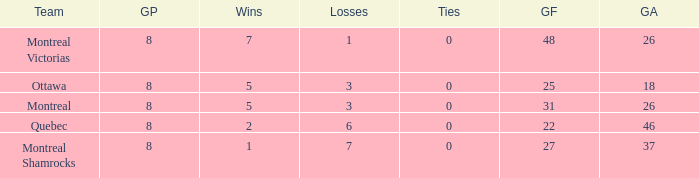For teams with 7 wins, what is the number of goals against? 26.0. 